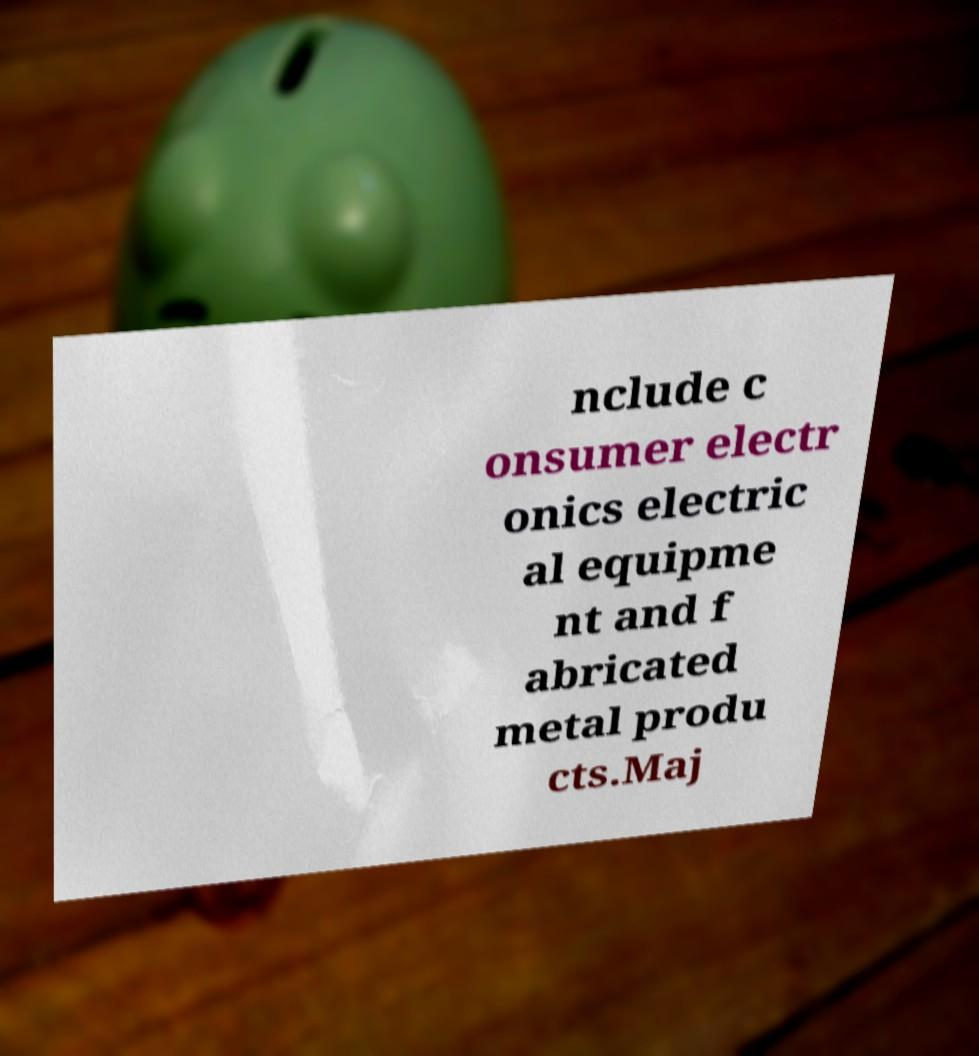Please read and relay the text visible in this image. What does it say? nclude c onsumer electr onics electric al equipme nt and f abricated metal produ cts.Maj 